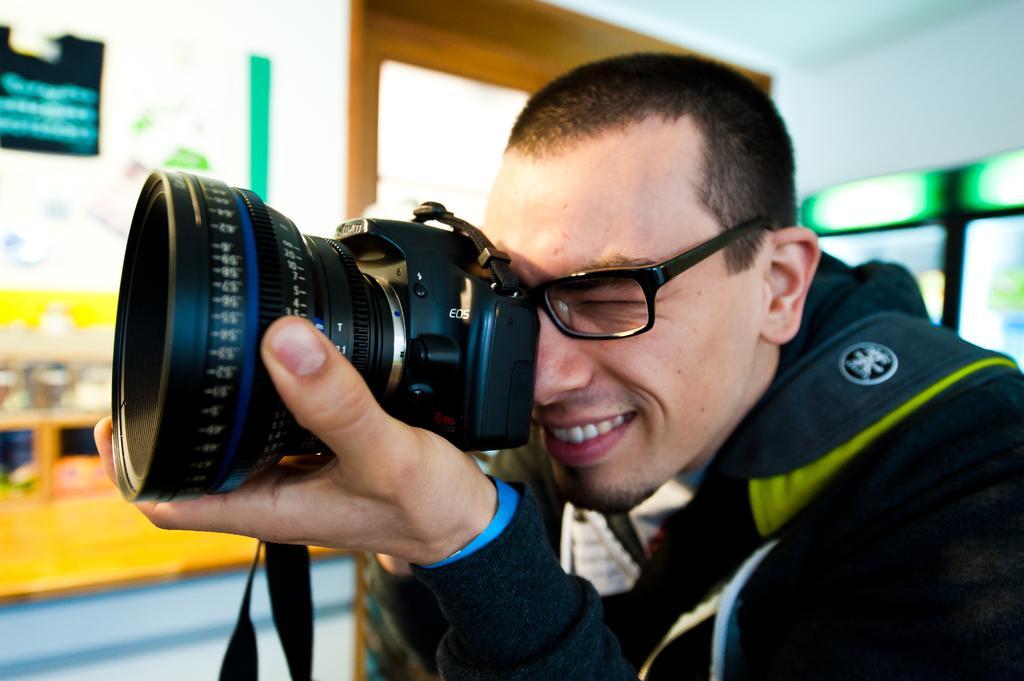Describe this image in one or two sentences. In this image there is a person wearing black color jacket holding a camera in his hand. 